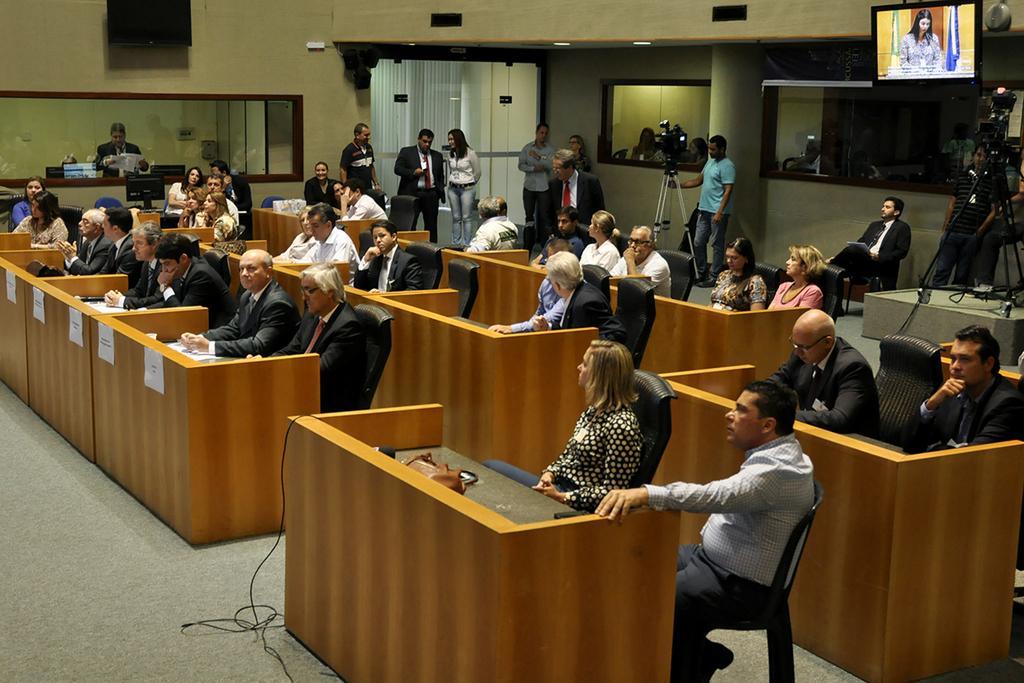Describe this image in one or two sentences. There are many people sitting in the chairs in front of their tables, those are like cabins. There are men and women. In the background some of them are standing. We can observe a video camera here and a television. There is a wall here. 